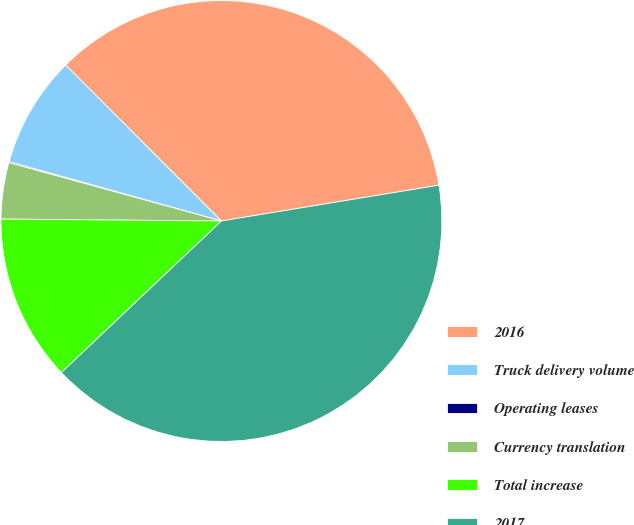Convert chart. <chart><loc_0><loc_0><loc_500><loc_500><pie_chart><fcel>2016<fcel>Truck delivery volume<fcel>Operating leases<fcel>Currency translation<fcel>Total increase<fcel>2017<nl><fcel>34.89%<fcel>8.17%<fcel>0.08%<fcel>4.12%<fcel>12.21%<fcel>40.53%<nl></chart> 